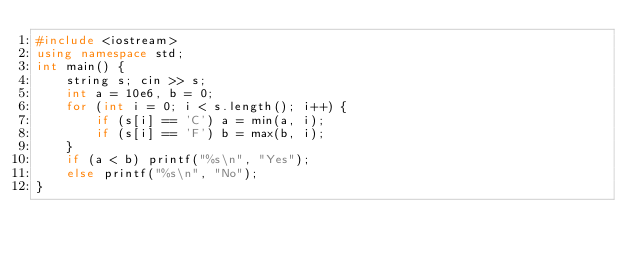<code> <loc_0><loc_0><loc_500><loc_500><_C++_>#include <iostream>
using namespace std;
int main() {
    string s; cin >> s;
    int a = 10e6, b = 0;
    for (int i = 0; i < s.length(); i++) {
        if (s[i] == 'C') a = min(a, i);
        if (s[i] == 'F') b = max(b, i);
    }
    if (a < b) printf("%s\n", "Yes");
    else printf("%s\n", "No");
}</code> 